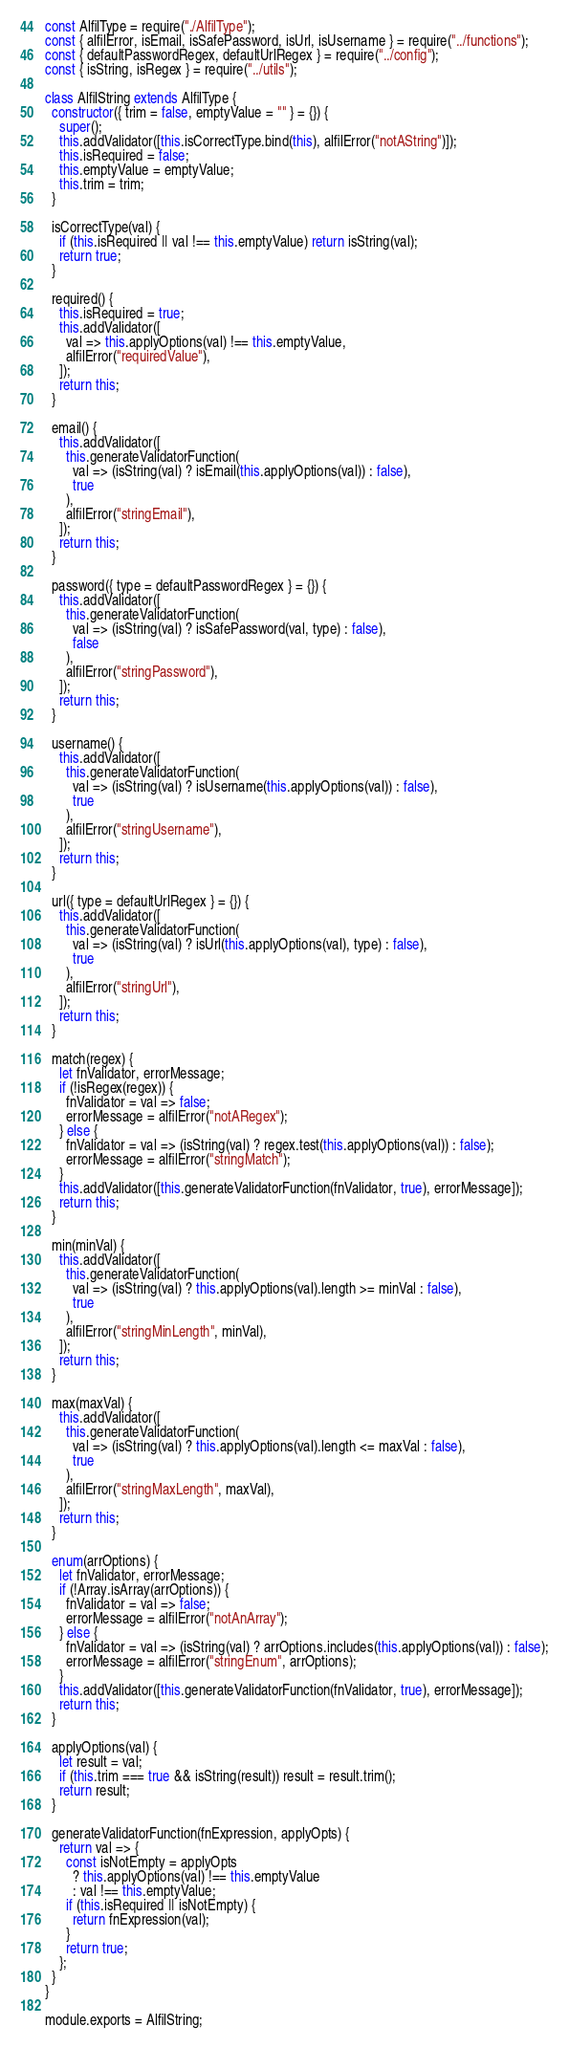<code> <loc_0><loc_0><loc_500><loc_500><_JavaScript_>const AlfilType = require("./AlfilType");
const { alfilError, isEmail, isSafePassword, isUrl, isUsername } = require("../functions");
const { defaultPasswordRegex, defaultUrlRegex } = require("../config");
const { isString, isRegex } = require("../utils");

class AlfilString extends AlfilType {
  constructor({ trim = false, emptyValue = "" } = {}) {
    super();
    this.addValidator([this.isCorrectType.bind(this), alfilError("notAString")]);
    this.isRequired = false;
    this.emptyValue = emptyValue;
    this.trim = trim;
  }

  isCorrectType(val) {
    if (this.isRequired || val !== this.emptyValue) return isString(val);
    return true;
  }

  required() {
    this.isRequired = true;
    this.addValidator([
      val => this.applyOptions(val) !== this.emptyValue,
      alfilError("requiredValue"),
    ]);
    return this;
  }

  email() {
    this.addValidator([
      this.generateValidatorFunction(
        val => (isString(val) ? isEmail(this.applyOptions(val)) : false),
        true
      ),
      alfilError("stringEmail"),
    ]);
    return this;
  }

  password({ type = defaultPasswordRegex } = {}) {
    this.addValidator([
      this.generateValidatorFunction(
        val => (isString(val) ? isSafePassword(val, type) : false),
        false
      ),
      alfilError("stringPassword"),
    ]);
    return this;
  }

  username() {
    this.addValidator([
      this.generateValidatorFunction(
        val => (isString(val) ? isUsername(this.applyOptions(val)) : false),
        true
      ),
      alfilError("stringUsername"),
    ]);
    return this;
  }

  url({ type = defaultUrlRegex } = {}) {
    this.addValidator([
      this.generateValidatorFunction(
        val => (isString(val) ? isUrl(this.applyOptions(val), type) : false),
        true
      ),
      alfilError("stringUrl"),
    ]);
    return this;
  }

  match(regex) {
    let fnValidator, errorMessage;
    if (!isRegex(regex)) {
      fnValidator = val => false;
      errorMessage = alfilError("notARegex");
    } else {
      fnValidator = val => (isString(val) ? regex.test(this.applyOptions(val)) : false);
      errorMessage = alfilError("stringMatch");
    }
    this.addValidator([this.generateValidatorFunction(fnValidator, true), errorMessage]);
    return this;
  }

  min(minVal) {
    this.addValidator([
      this.generateValidatorFunction(
        val => (isString(val) ? this.applyOptions(val).length >= minVal : false),
        true
      ),
      alfilError("stringMinLength", minVal),
    ]);
    return this;
  }

  max(maxVal) {
    this.addValidator([
      this.generateValidatorFunction(
        val => (isString(val) ? this.applyOptions(val).length <= maxVal : false),
        true
      ),
      alfilError("stringMaxLength", maxVal),
    ]);
    return this;
  }

  enum(arrOptions) {
    let fnValidator, errorMessage;
    if (!Array.isArray(arrOptions)) {
      fnValidator = val => false;
      errorMessage = alfilError("notAnArray");
    } else {
      fnValidator = val => (isString(val) ? arrOptions.includes(this.applyOptions(val)) : false);
      errorMessage = alfilError("stringEnum", arrOptions);
    }
    this.addValidator([this.generateValidatorFunction(fnValidator, true), errorMessage]);
    return this;
  }

  applyOptions(val) {
    let result = val;
    if (this.trim === true && isString(result)) result = result.trim();
    return result;
  }

  generateValidatorFunction(fnExpression, applyOpts) {
    return val => {
      const isNotEmpty = applyOpts
        ? this.applyOptions(val) !== this.emptyValue
        : val !== this.emptyValue;
      if (this.isRequired || isNotEmpty) {
        return fnExpression(val);
      }
      return true;
    };
  }
}

module.exports = AlfilString;
</code> 